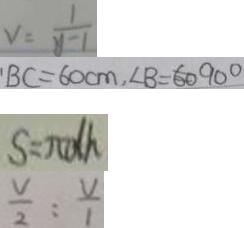Convert formula to latex. <formula><loc_0><loc_0><loc_500><loc_500>v = \frac { 1 } { y - 1 } 
 B C = 6 0 c m , \angle B = 6 0 ^ { \circ } 
 S = \pi d h 
 \frac { V } { 2 } : \frac { V } { 1 }</formula> 